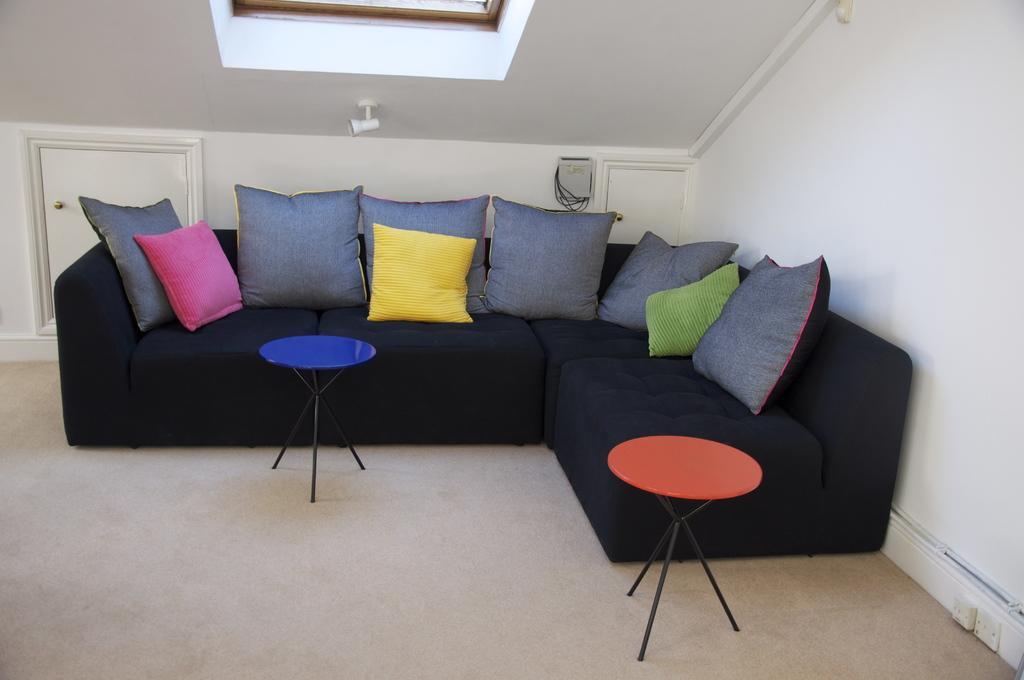Could you give a brief overview of what you see in this image? The image is inside the room. In the image from right side to left side we can see a couch, on couch there are few pillows and a table in background there is a door and a wall which are in white color. 